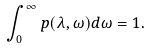Convert formula to latex. <formula><loc_0><loc_0><loc_500><loc_500>\int _ { 0 } ^ { \infty } p ( \lambda , \omega ) d \omega = 1 .</formula> 